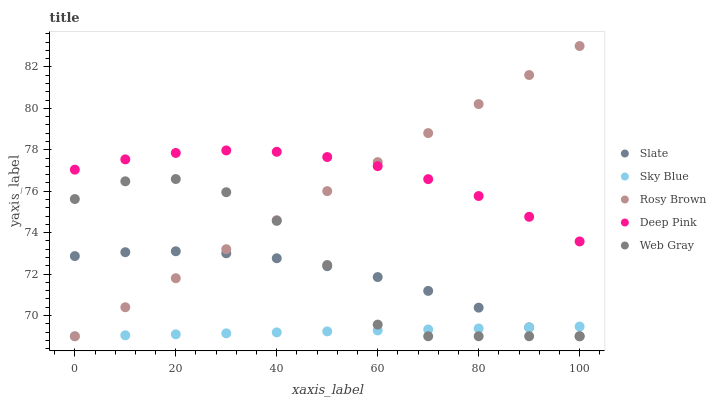Does Sky Blue have the minimum area under the curve?
Answer yes or no. Yes. Does Deep Pink have the maximum area under the curve?
Answer yes or no. Yes. Does Slate have the minimum area under the curve?
Answer yes or no. No. Does Slate have the maximum area under the curve?
Answer yes or no. No. Is Sky Blue the smoothest?
Answer yes or no. Yes. Is Web Gray the roughest?
Answer yes or no. Yes. Is Slate the smoothest?
Answer yes or no. No. Is Slate the roughest?
Answer yes or no. No. Does Sky Blue have the lowest value?
Answer yes or no. Yes. Does Deep Pink have the lowest value?
Answer yes or no. No. Does Rosy Brown have the highest value?
Answer yes or no. Yes. Does Slate have the highest value?
Answer yes or no. No. Is Slate less than Deep Pink?
Answer yes or no. Yes. Is Deep Pink greater than Slate?
Answer yes or no. Yes. Does Web Gray intersect Slate?
Answer yes or no. Yes. Is Web Gray less than Slate?
Answer yes or no. No. Is Web Gray greater than Slate?
Answer yes or no. No. Does Slate intersect Deep Pink?
Answer yes or no. No. 